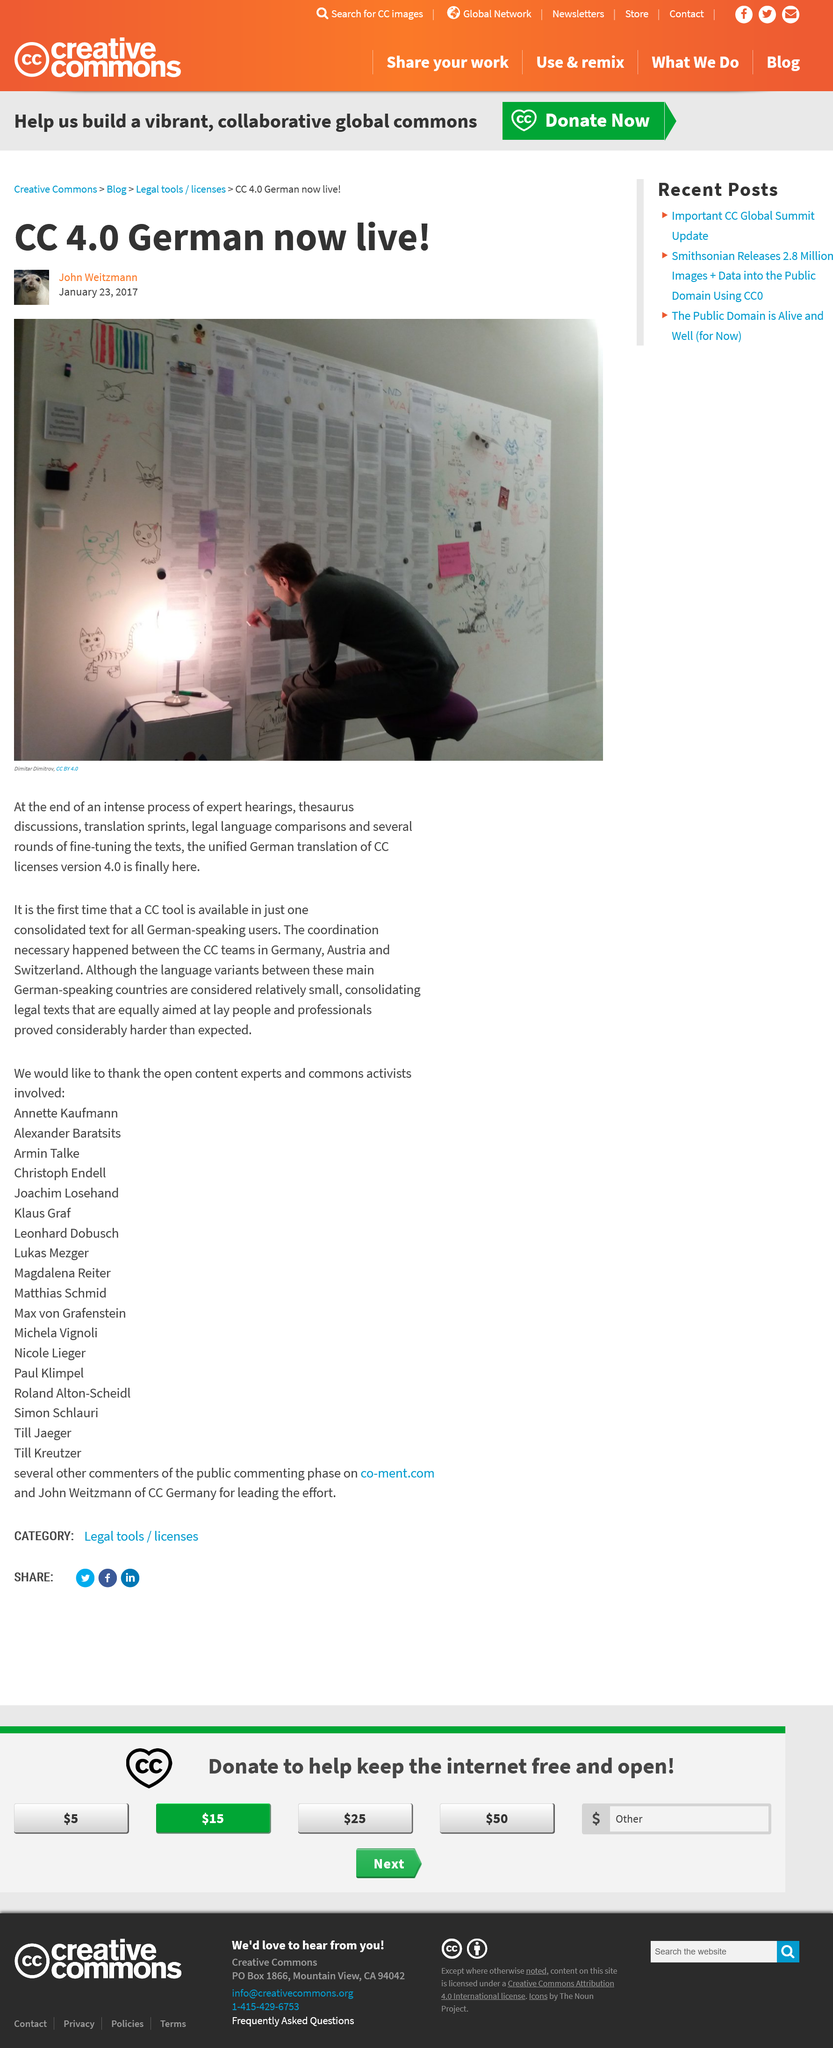Draw attention to some important aspects in this diagram. The final version of the license has arrived: version 4.0. The author of this article is John Weitzmann. 